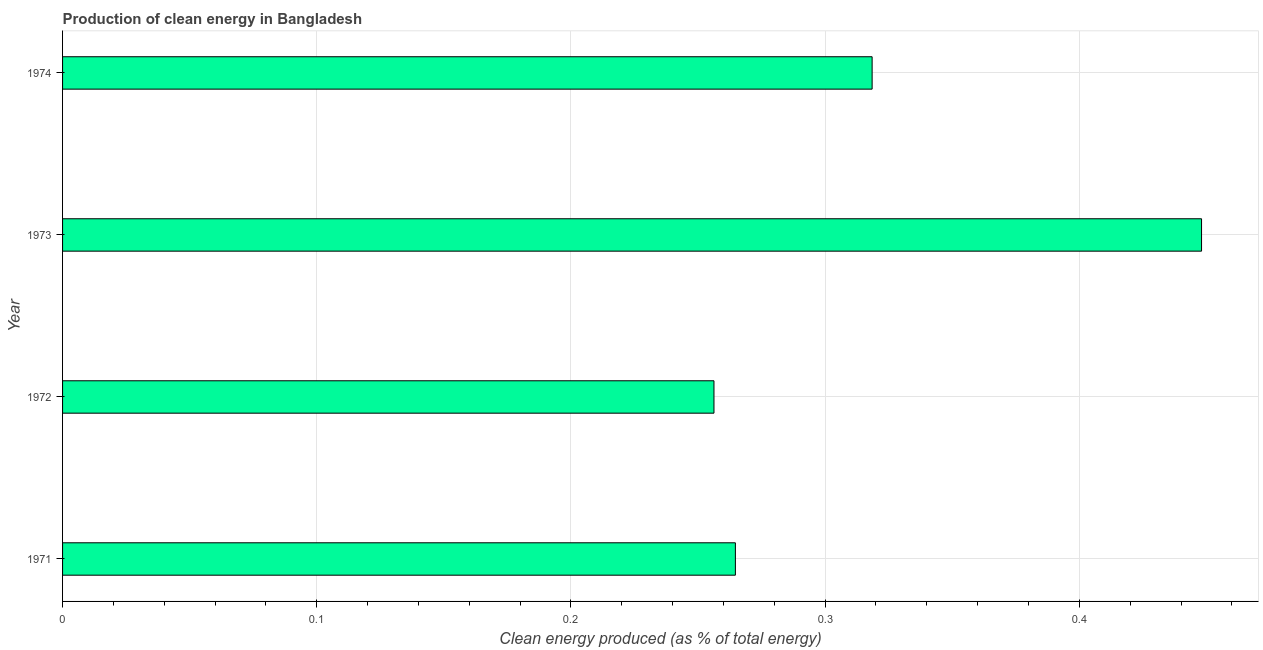Does the graph contain any zero values?
Give a very brief answer. No. What is the title of the graph?
Keep it short and to the point. Production of clean energy in Bangladesh. What is the label or title of the X-axis?
Keep it short and to the point. Clean energy produced (as % of total energy). What is the label or title of the Y-axis?
Your response must be concise. Year. What is the production of clean energy in 1973?
Keep it short and to the point. 0.45. Across all years, what is the maximum production of clean energy?
Offer a terse response. 0.45. Across all years, what is the minimum production of clean energy?
Keep it short and to the point. 0.26. In which year was the production of clean energy maximum?
Your response must be concise. 1973. In which year was the production of clean energy minimum?
Provide a succinct answer. 1972. What is the sum of the production of clean energy?
Your answer should be very brief. 1.29. What is the difference between the production of clean energy in 1971 and 1973?
Offer a very short reply. -0.18. What is the average production of clean energy per year?
Provide a short and direct response. 0.32. What is the median production of clean energy?
Your response must be concise. 0.29. In how many years, is the production of clean energy greater than 0.26 %?
Provide a succinct answer. 3. Do a majority of the years between 1974 and 1973 (inclusive) have production of clean energy greater than 0.4 %?
Provide a succinct answer. No. What is the ratio of the production of clean energy in 1972 to that in 1974?
Give a very brief answer. 0.81. What is the difference between the highest and the second highest production of clean energy?
Offer a very short reply. 0.13. Is the sum of the production of clean energy in 1971 and 1974 greater than the maximum production of clean energy across all years?
Keep it short and to the point. Yes. What is the difference between the highest and the lowest production of clean energy?
Your answer should be compact. 0.19. How many bars are there?
Offer a very short reply. 4. What is the difference between two consecutive major ticks on the X-axis?
Provide a short and direct response. 0.1. What is the Clean energy produced (as % of total energy) of 1971?
Make the answer very short. 0.26. What is the Clean energy produced (as % of total energy) of 1972?
Your answer should be compact. 0.26. What is the Clean energy produced (as % of total energy) in 1973?
Make the answer very short. 0.45. What is the Clean energy produced (as % of total energy) of 1974?
Offer a terse response. 0.32. What is the difference between the Clean energy produced (as % of total energy) in 1971 and 1972?
Your response must be concise. 0.01. What is the difference between the Clean energy produced (as % of total energy) in 1971 and 1973?
Your answer should be very brief. -0.18. What is the difference between the Clean energy produced (as % of total energy) in 1971 and 1974?
Offer a terse response. -0.05. What is the difference between the Clean energy produced (as % of total energy) in 1972 and 1973?
Give a very brief answer. -0.19. What is the difference between the Clean energy produced (as % of total energy) in 1972 and 1974?
Provide a short and direct response. -0.06. What is the difference between the Clean energy produced (as % of total energy) in 1973 and 1974?
Provide a short and direct response. 0.13. What is the ratio of the Clean energy produced (as % of total energy) in 1971 to that in 1972?
Provide a short and direct response. 1.03. What is the ratio of the Clean energy produced (as % of total energy) in 1971 to that in 1973?
Your answer should be very brief. 0.59. What is the ratio of the Clean energy produced (as % of total energy) in 1971 to that in 1974?
Give a very brief answer. 0.83. What is the ratio of the Clean energy produced (as % of total energy) in 1972 to that in 1973?
Keep it short and to the point. 0.57. What is the ratio of the Clean energy produced (as % of total energy) in 1972 to that in 1974?
Ensure brevity in your answer.  0.81. What is the ratio of the Clean energy produced (as % of total energy) in 1973 to that in 1974?
Make the answer very short. 1.41. 